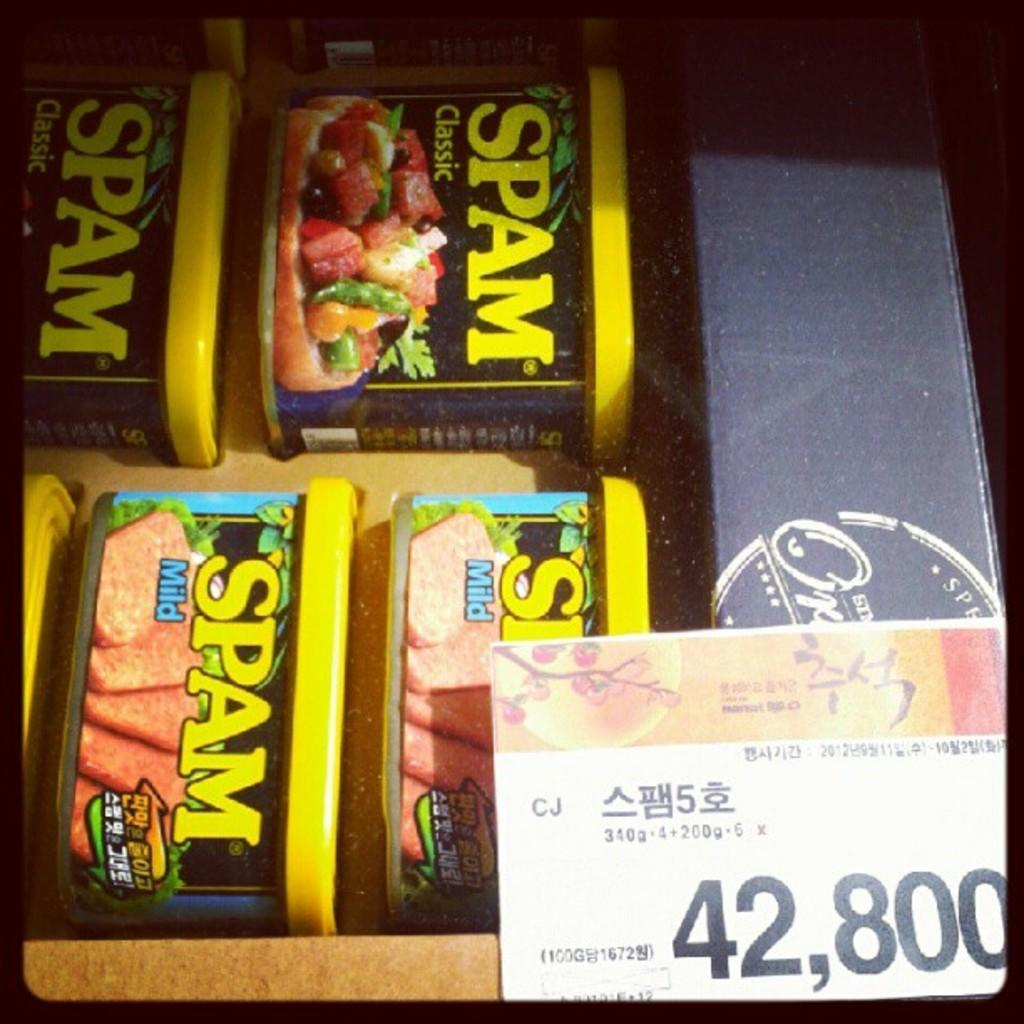What objects are present in the image that have stickers on them? There are boxes with stickers in the image. Where is the price tag located in the image? The price tag is on the right side, bottom of the image. What color are the borders of the image? The borders of the image are black. How many lizards can be seen climbing on the boxes in the image? There are no lizards present in the image; it only features boxes with stickers and a price tag. 